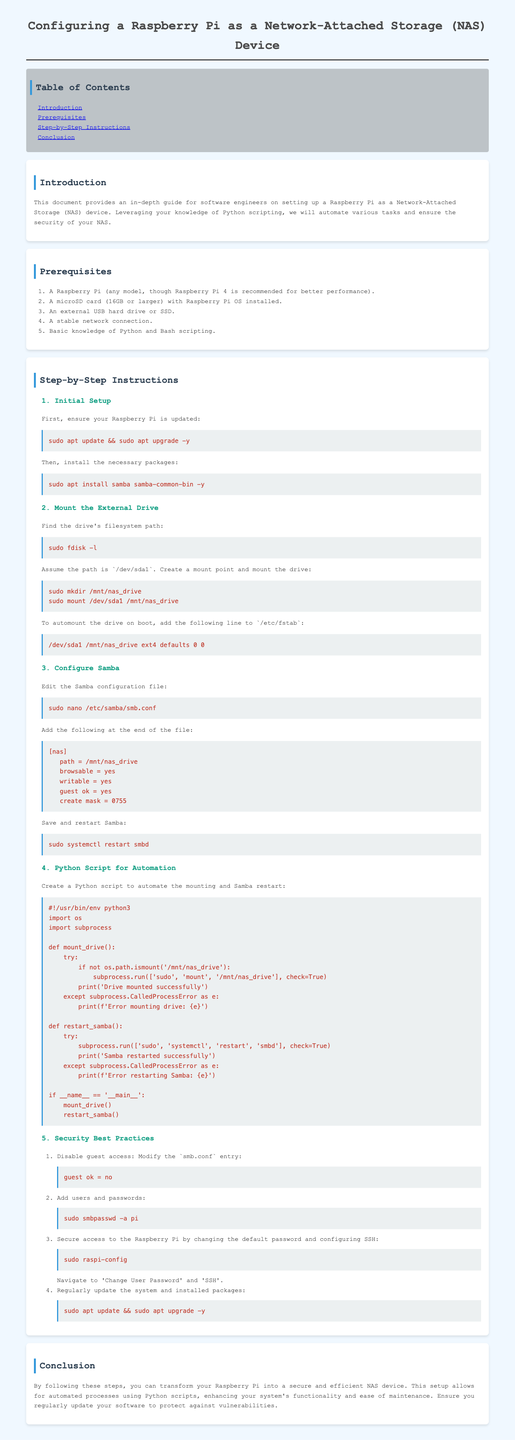What is the recommended Raspberry Pi model for better performance? The document states that Raspberry Pi 4 is recommended for better performance.
Answer: Raspberry Pi 4 What command is used to update the Raspberry Pi? The command provided in the document for updating the Raspberry Pi is 'sudo apt update && sudo apt upgrade -y'.
Answer: sudo apt update && sudo apt upgrade -y Where should the external drive be mounted? The document specifies that the external drive should be mounted at '/mnt/nas_drive'.
Answer: /mnt/nas_drive How many steps are included in the step-by-step instructions? The document lists five distinct steps in the step-by-step instructions section.
Answer: Five What should be added to the Samba configuration file to improve security? The document recommends changing the setting to 'guest ok = no' to enhance security.
Answer: guest ok = no What is the purpose of the Python script provided? The document states that the Python script is designed to automate the mounting of the drive and the restart of Samba.
Answer: Automate mounting and Samba restart How can you create a mount point for the external drive? The command in the document to create a mount point for the drive is 'sudo mkdir /mnt/nas_drive'.
Answer: sudo mkdir /mnt/nas_drive What is the final section of the document titled? The title of the final section in the document is 'Conclusion'.
Answer: Conclusion 